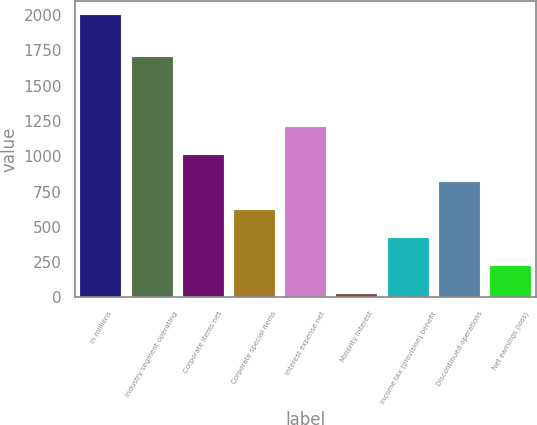Convert chart. <chart><loc_0><loc_0><loc_500><loc_500><bar_chart><fcel>In millions<fcel>Industry segment operating<fcel>Corporate items net<fcel>Corporate special items<fcel>Interest expense net<fcel>Minority interest<fcel>Income tax (provision) benefit<fcel>Discontinued operations<fcel>Net earnings (loss)<nl><fcel>2004<fcel>1703<fcel>1012.5<fcel>615.9<fcel>1210.8<fcel>21<fcel>417.6<fcel>814.2<fcel>219.3<nl></chart> 